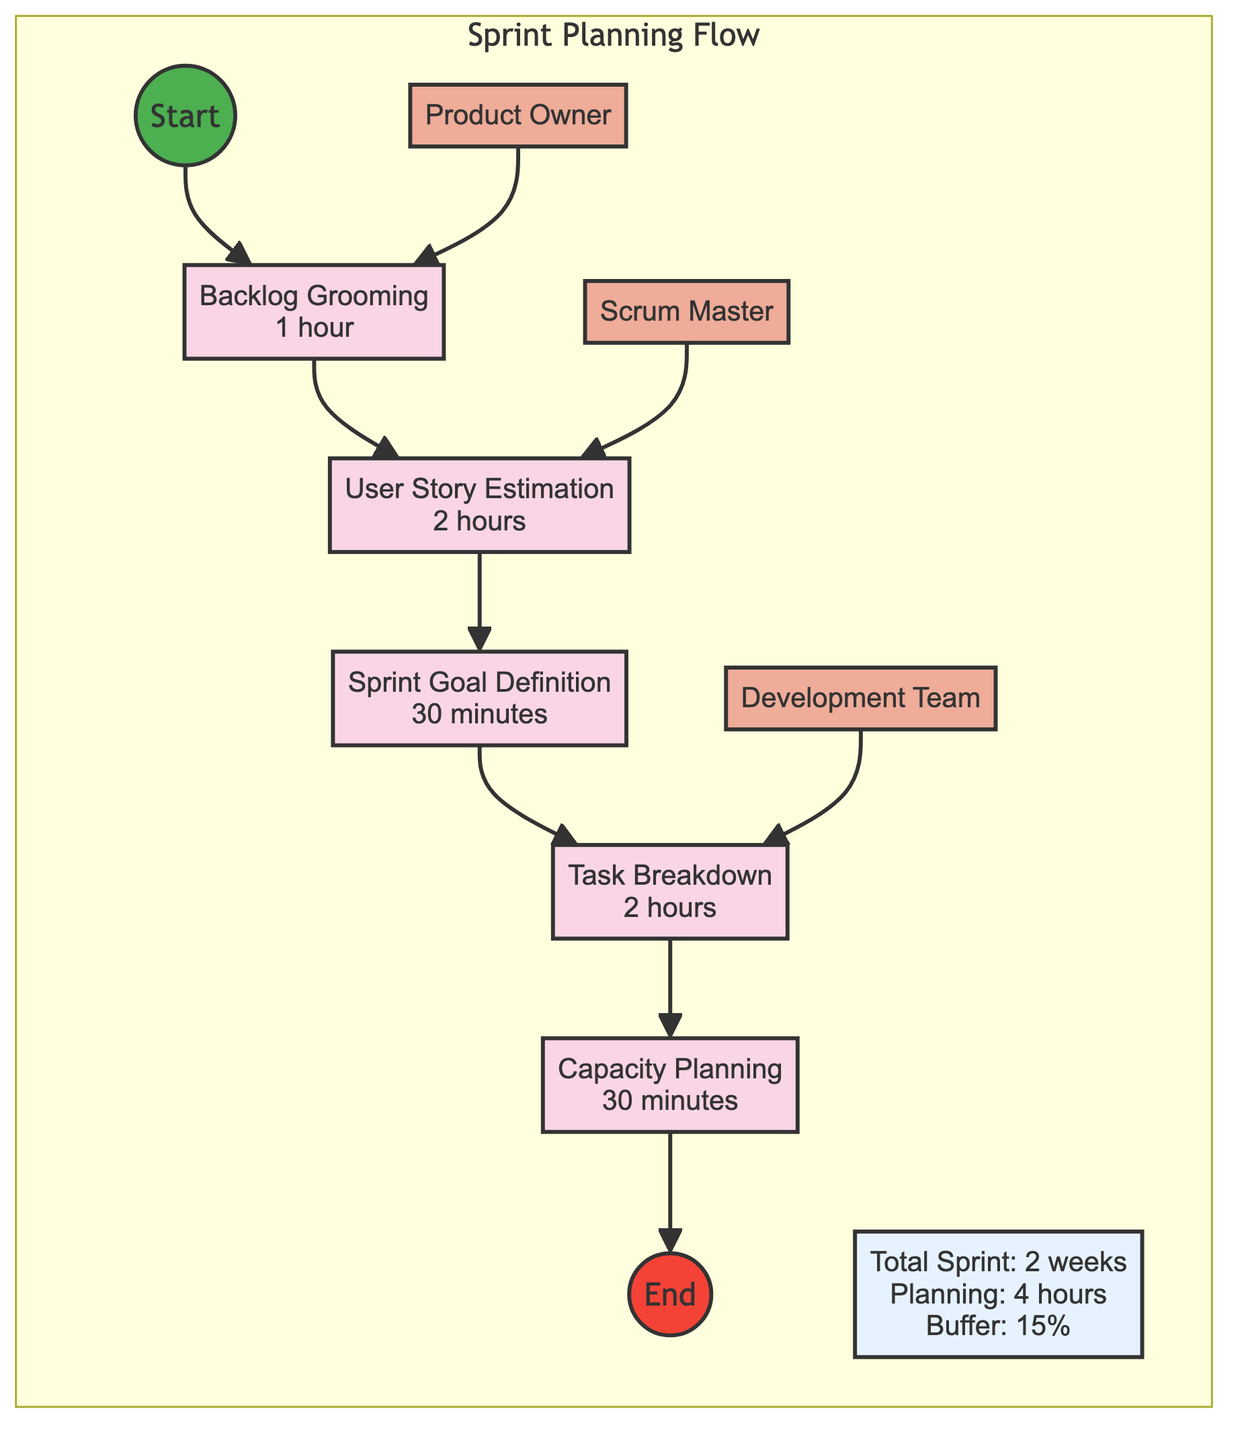What is the total duration allocated for sprint planning? The diagram clearly states the total duration for sprint planning at the top. It shows "Planning: 4 hours" as one of the time allocation details. Thus, the direct reading of this information provides the total duration.
Answer: 4 hours Which task comes first in the sprint planning flow? By following the directed arrows starting from the "Start" node, the first task node connected is "Backlog Grooming." This can be observed as the first step in the flowchart.
Answer: Backlog Grooming Who is responsible for the User Story Estimation task? The diagram identifies roles and their associated tasks. The "Scrum Master" node has a directed connection to the "User Story Estimation" node. Therefore, the responsibility can be traced back directly to the Scrum Master in the diagram.
Answer: Scrum Master How many tasks are included in the sprint planning? The diagram includes a list of tasks contained within the "Sprint Planning Flow" subgraph. By counting the task nodes presented - Backlog Grooming, User Story Estimation, Sprint Goal Definition, Task Breakdown, and Capacity Planning - we find there are five distinct tasks.
Answer: 5 What is the role of the Product Owner? The diagram outlines the roles and responsibilities of team members. The "Product Owner" is connected to the "Backlog Grooming" task, with the associated responsibility described as "Defines the product vision and prioritizes backlog items." This is a direct reading from the diagram.
Answer: Defines the product vision and prioritizes backlog items What is the duration of the Sprint Goal Definition task? Each task node in the flowchart displays both the task name and its duration. The "Sprint Goal Definition" task shows "30 minutes" as its duration directly next to the task name.
Answer: 30 minutes What percentage of buffer time is allocated in the sprint planning? The "Buffer" time detail stated in the time allocation section of the diagram is indicated as "15%." This is a straightforward reference directly found within the time allocation summary.
Answer: 15% Which role facilitates the sprint planning process? The flowchart indicates roles through direct connections to tasks. The "Scrum Master" is connected to "User Story Estimation," which aligns with the responsibility to facilitate the sprint planning process. This relationship is depicted clearly in the diagram.
Answer: Scrum Master What is the total duration of the sprint? The total duration of the sprint is denoted within the time allocation section of the flowchart by stating "Total Sprint: 2 weeks." This duration is explicitly detailed in the flowchart itself.
Answer: 2 weeks 